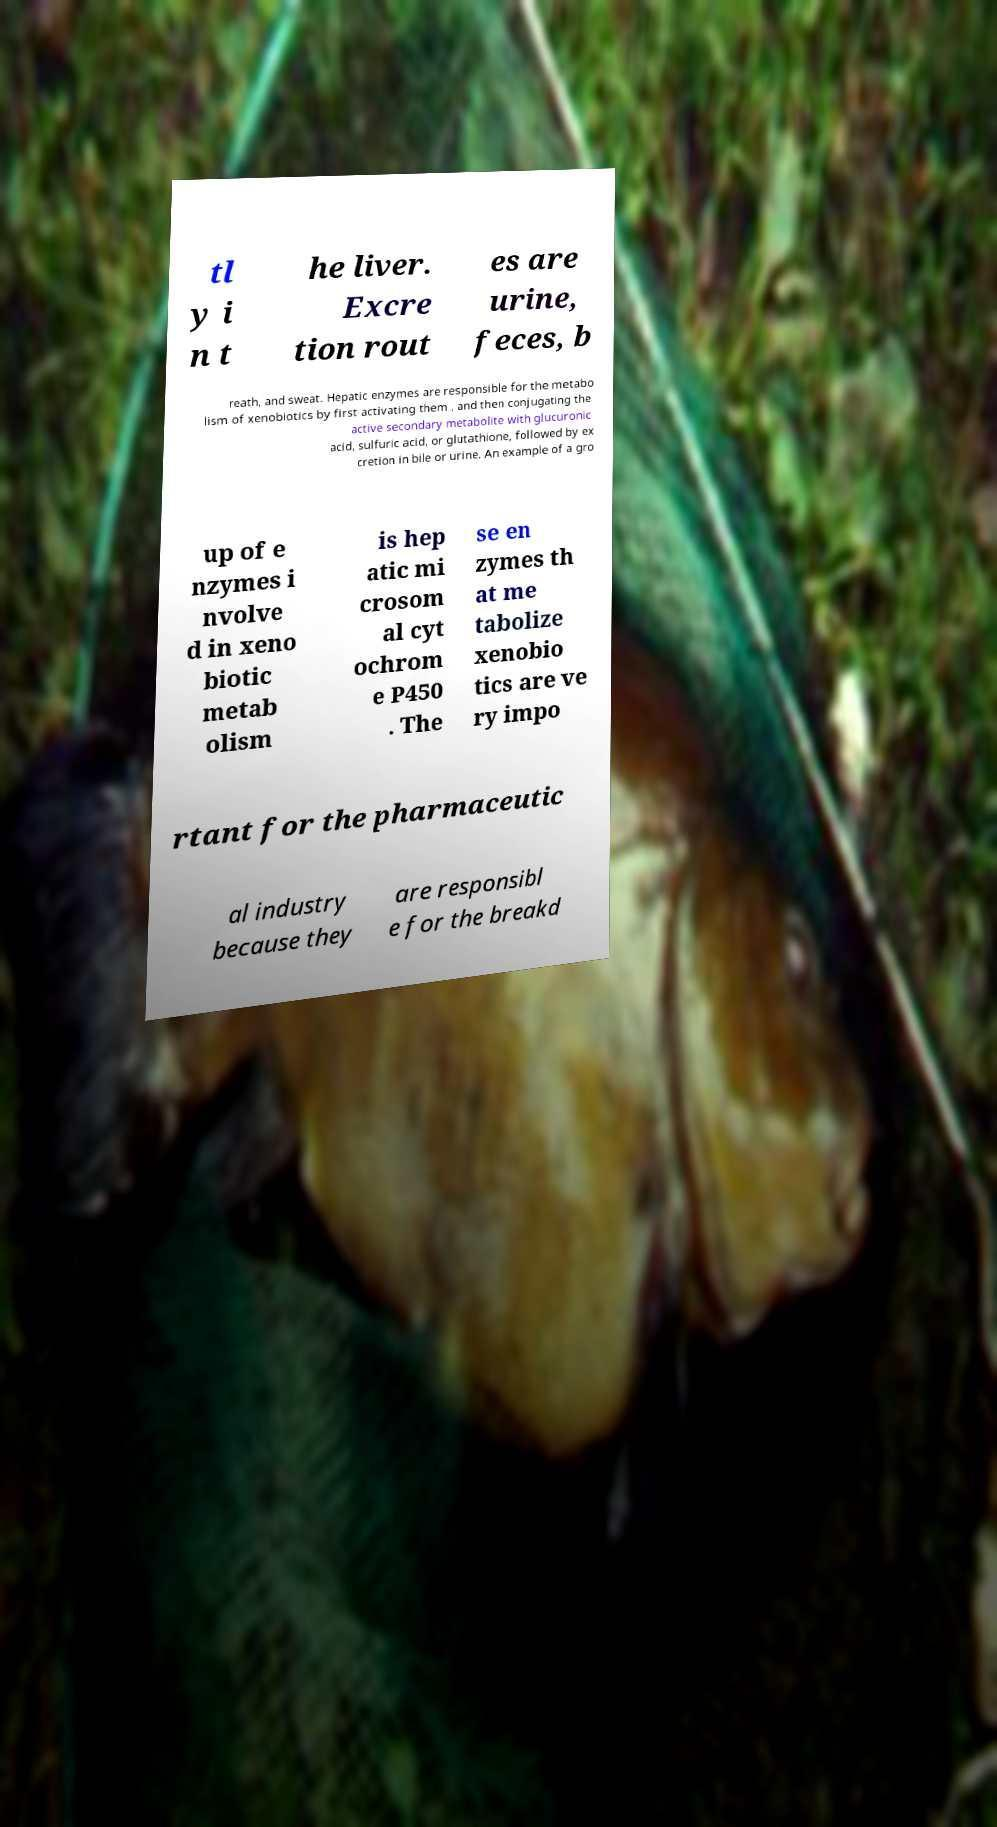Could you extract and type out the text from this image? tl y i n t he liver. Excre tion rout es are urine, feces, b reath, and sweat. Hepatic enzymes are responsible for the metabo lism of xenobiotics by first activating them , and then conjugating the active secondary metabolite with glucuronic acid, sulfuric acid, or glutathione, followed by ex cretion in bile or urine. An example of a gro up of e nzymes i nvolve d in xeno biotic metab olism is hep atic mi crosom al cyt ochrom e P450 . The se en zymes th at me tabolize xenobio tics are ve ry impo rtant for the pharmaceutic al industry because they are responsibl e for the breakd 